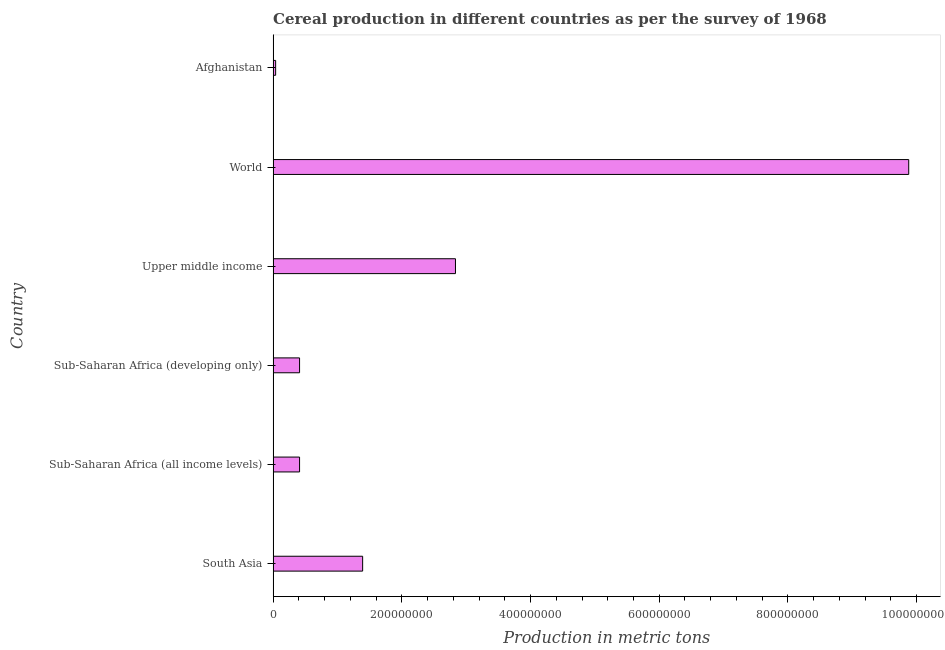What is the title of the graph?
Ensure brevity in your answer.  Cereal production in different countries as per the survey of 1968. What is the label or title of the X-axis?
Offer a terse response. Production in metric tons. What is the label or title of the Y-axis?
Provide a succinct answer. Country. What is the cereal production in Upper middle income?
Keep it short and to the point. 2.83e+08. Across all countries, what is the maximum cereal production?
Offer a terse response. 9.88e+08. Across all countries, what is the minimum cereal production?
Offer a very short reply. 3.92e+06. In which country was the cereal production minimum?
Provide a succinct answer. Afghanistan. What is the sum of the cereal production?
Ensure brevity in your answer.  1.50e+09. What is the difference between the cereal production in Sub-Saharan Africa (all income levels) and Upper middle income?
Your response must be concise. -2.42e+08. What is the average cereal production per country?
Provide a short and direct response. 2.49e+08. What is the median cereal production?
Give a very brief answer. 9.01e+07. In how many countries, is the cereal production greater than 120000000 metric tons?
Provide a short and direct response. 3. What is the ratio of the cereal production in Sub-Saharan Africa (developing only) to that in World?
Provide a short and direct response. 0.04. Is the cereal production in Sub-Saharan Africa (all income levels) less than that in Sub-Saharan Africa (developing only)?
Give a very brief answer. No. Is the difference between the cereal production in Afghanistan and South Asia greater than the difference between any two countries?
Your answer should be compact. No. What is the difference between the highest and the second highest cereal production?
Provide a succinct answer. 7.04e+08. What is the difference between the highest and the lowest cereal production?
Ensure brevity in your answer.  9.84e+08. How many bars are there?
Your answer should be very brief. 6. Are all the bars in the graph horizontal?
Provide a succinct answer. Yes. What is the Production in metric tons in South Asia?
Your response must be concise. 1.39e+08. What is the Production in metric tons of Sub-Saharan Africa (all income levels)?
Keep it short and to the point. 4.11e+07. What is the Production in metric tons of Sub-Saharan Africa (developing only)?
Give a very brief answer. 4.11e+07. What is the Production in metric tons in Upper middle income?
Give a very brief answer. 2.83e+08. What is the Production in metric tons of World?
Provide a succinct answer. 9.88e+08. What is the Production in metric tons of Afghanistan?
Provide a succinct answer. 3.92e+06. What is the difference between the Production in metric tons in South Asia and Sub-Saharan Africa (all income levels)?
Your answer should be very brief. 9.80e+07. What is the difference between the Production in metric tons in South Asia and Sub-Saharan Africa (developing only)?
Your response must be concise. 9.80e+07. What is the difference between the Production in metric tons in South Asia and Upper middle income?
Your answer should be compact. -1.44e+08. What is the difference between the Production in metric tons in South Asia and World?
Offer a very short reply. -8.49e+08. What is the difference between the Production in metric tons in South Asia and Afghanistan?
Keep it short and to the point. 1.35e+08. What is the difference between the Production in metric tons in Sub-Saharan Africa (all income levels) and Sub-Saharan Africa (developing only)?
Your answer should be very brief. 0. What is the difference between the Production in metric tons in Sub-Saharan Africa (all income levels) and Upper middle income?
Your answer should be compact. -2.42e+08. What is the difference between the Production in metric tons in Sub-Saharan Africa (all income levels) and World?
Keep it short and to the point. -9.47e+08. What is the difference between the Production in metric tons in Sub-Saharan Africa (all income levels) and Afghanistan?
Provide a succinct answer. 3.72e+07. What is the difference between the Production in metric tons in Sub-Saharan Africa (developing only) and Upper middle income?
Offer a terse response. -2.42e+08. What is the difference between the Production in metric tons in Sub-Saharan Africa (developing only) and World?
Make the answer very short. -9.47e+08. What is the difference between the Production in metric tons in Sub-Saharan Africa (developing only) and Afghanistan?
Give a very brief answer. 3.72e+07. What is the difference between the Production in metric tons in Upper middle income and World?
Keep it short and to the point. -7.04e+08. What is the difference between the Production in metric tons in Upper middle income and Afghanistan?
Ensure brevity in your answer.  2.79e+08. What is the difference between the Production in metric tons in World and Afghanistan?
Ensure brevity in your answer.  9.84e+08. What is the ratio of the Production in metric tons in South Asia to that in Sub-Saharan Africa (all income levels)?
Your response must be concise. 3.38. What is the ratio of the Production in metric tons in South Asia to that in Sub-Saharan Africa (developing only)?
Provide a short and direct response. 3.38. What is the ratio of the Production in metric tons in South Asia to that in Upper middle income?
Give a very brief answer. 0.49. What is the ratio of the Production in metric tons in South Asia to that in World?
Give a very brief answer. 0.14. What is the ratio of the Production in metric tons in South Asia to that in Afghanistan?
Your answer should be compact. 35.52. What is the ratio of the Production in metric tons in Sub-Saharan Africa (all income levels) to that in Upper middle income?
Provide a short and direct response. 0.14. What is the ratio of the Production in metric tons in Sub-Saharan Africa (all income levels) to that in World?
Your answer should be very brief. 0.04. What is the ratio of the Production in metric tons in Sub-Saharan Africa (all income levels) to that in Afghanistan?
Offer a very short reply. 10.49. What is the ratio of the Production in metric tons in Sub-Saharan Africa (developing only) to that in Upper middle income?
Your answer should be very brief. 0.14. What is the ratio of the Production in metric tons in Sub-Saharan Africa (developing only) to that in World?
Offer a terse response. 0.04. What is the ratio of the Production in metric tons in Sub-Saharan Africa (developing only) to that in Afghanistan?
Your answer should be compact. 10.49. What is the ratio of the Production in metric tons in Upper middle income to that in World?
Give a very brief answer. 0.29. What is the ratio of the Production in metric tons in Upper middle income to that in Afghanistan?
Offer a terse response. 72.36. What is the ratio of the Production in metric tons in World to that in Afghanistan?
Provide a short and direct response. 252.22. 